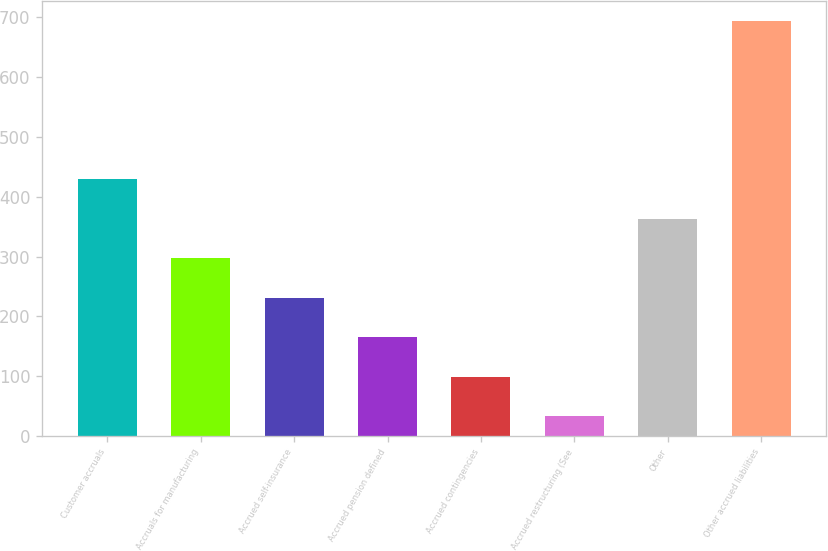Convert chart. <chart><loc_0><loc_0><loc_500><loc_500><bar_chart><fcel>Customer accruals<fcel>Accruals for manufacturing<fcel>Accrued self-insurance<fcel>Accrued pension defined<fcel>Accrued contingencies<fcel>Accrued restructuring (See<fcel>Other<fcel>Other accrued liabilities<nl><fcel>429.3<fcel>297.2<fcel>231.15<fcel>165.1<fcel>99.05<fcel>33<fcel>363.25<fcel>693.5<nl></chart> 